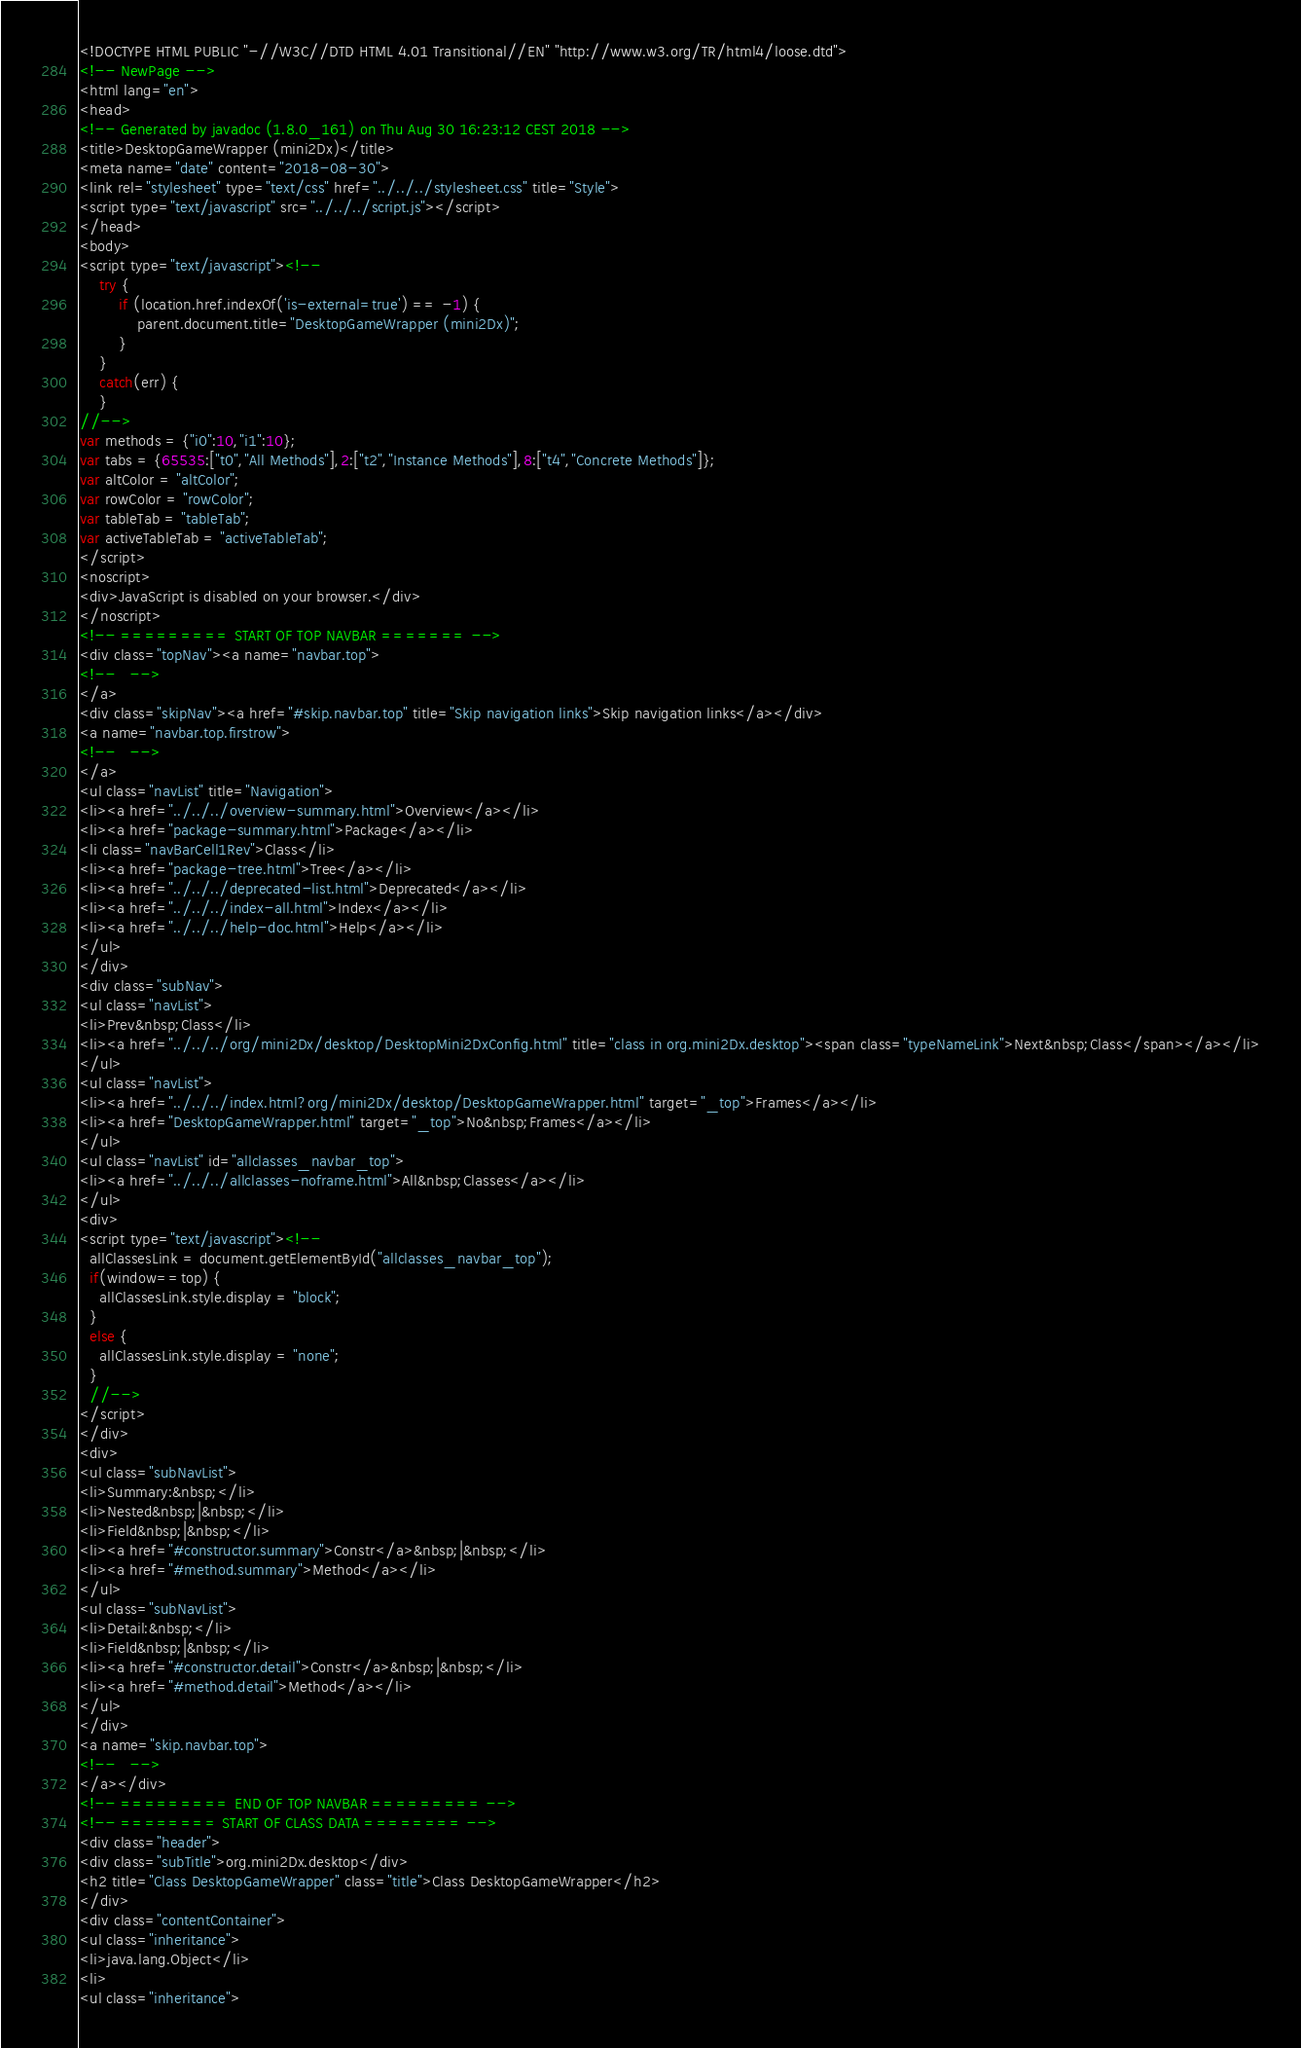<code> <loc_0><loc_0><loc_500><loc_500><_HTML_><!DOCTYPE HTML PUBLIC "-//W3C//DTD HTML 4.01 Transitional//EN" "http://www.w3.org/TR/html4/loose.dtd">
<!-- NewPage -->
<html lang="en">
<head>
<!-- Generated by javadoc (1.8.0_161) on Thu Aug 30 16:23:12 CEST 2018 -->
<title>DesktopGameWrapper (mini2Dx)</title>
<meta name="date" content="2018-08-30">
<link rel="stylesheet" type="text/css" href="../../../stylesheet.css" title="Style">
<script type="text/javascript" src="../../../script.js"></script>
</head>
<body>
<script type="text/javascript"><!--
    try {
        if (location.href.indexOf('is-external=true') == -1) {
            parent.document.title="DesktopGameWrapper (mini2Dx)";
        }
    }
    catch(err) {
    }
//-->
var methods = {"i0":10,"i1":10};
var tabs = {65535:["t0","All Methods"],2:["t2","Instance Methods"],8:["t4","Concrete Methods"]};
var altColor = "altColor";
var rowColor = "rowColor";
var tableTab = "tableTab";
var activeTableTab = "activeTableTab";
</script>
<noscript>
<div>JavaScript is disabled on your browser.</div>
</noscript>
<!-- ========= START OF TOP NAVBAR ======= -->
<div class="topNav"><a name="navbar.top">
<!--   -->
</a>
<div class="skipNav"><a href="#skip.navbar.top" title="Skip navigation links">Skip navigation links</a></div>
<a name="navbar.top.firstrow">
<!--   -->
</a>
<ul class="navList" title="Navigation">
<li><a href="../../../overview-summary.html">Overview</a></li>
<li><a href="package-summary.html">Package</a></li>
<li class="navBarCell1Rev">Class</li>
<li><a href="package-tree.html">Tree</a></li>
<li><a href="../../../deprecated-list.html">Deprecated</a></li>
<li><a href="../../../index-all.html">Index</a></li>
<li><a href="../../../help-doc.html">Help</a></li>
</ul>
</div>
<div class="subNav">
<ul class="navList">
<li>Prev&nbsp;Class</li>
<li><a href="../../../org/mini2Dx/desktop/DesktopMini2DxConfig.html" title="class in org.mini2Dx.desktop"><span class="typeNameLink">Next&nbsp;Class</span></a></li>
</ul>
<ul class="navList">
<li><a href="../../../index.html?org/mini2Dx/desktop/DesktopGameWrapper.html" target="_top">Frames</a></li>
<li><a href="DesktopGameWrapper.html" target="_top">No&nbsp;Frames</a></li>
</ul>
<ul class="navList" id="allclasses_navbar_top">
<li><a href="../../../allclasses-noframe.html">All&nbsp;Classes</a></li>
</ul>
<div>
<script type="text/javascript"><!--
  allClassesLink = document.getElementById("allclasses_navbar_top");
  if(window==top) {
    allClassesLink.style.display = "block";
  }
  else {
    allClassesLink.style.display = "none";
  }
  //-->
</script>
</div>
<div>
<ul class="subNavList">
<li>Summary:&nbsp;</li>
<li>Nested&nbsp;|&nbsp;</li>
<li>Field&nbsp;|&nbsp;</li>
<li><a href="#constructor.summary">Constr</a>&nbsp;|&nbsp;</li>
<li><a href="#method.summary">Method</a></li>
</ul>
<ul class="subNavList">
<li>Detail:&nbsp;</li>
<li>Field&nbsp;|&nbsp;</li>
<li><a href="#constructor.detail">Constr</a>&nbsp;|&nbsp;</li>
<li><a href="#method.detail">Method</a></li>
</ul>
</div>
<a name="skip.navbar.top">
<!--   -->
</a></div>
<!-- ========= END OF TOP NAVBAR ========= -->
<!-- ======== START OF CLASS DATA ======== -->
<div class="header">
<div class="subTitle">org.mini2Dx.desktop</div>
<h2 title="Class DesktopGameWrapper" class="title">Class DesktopGameWrapper</h2>
</div>
<div class="contentContainer">
<ul class="inheritance">
<li>java.lang.Object</li>
<li>
<ul class="inheritance"></code> 